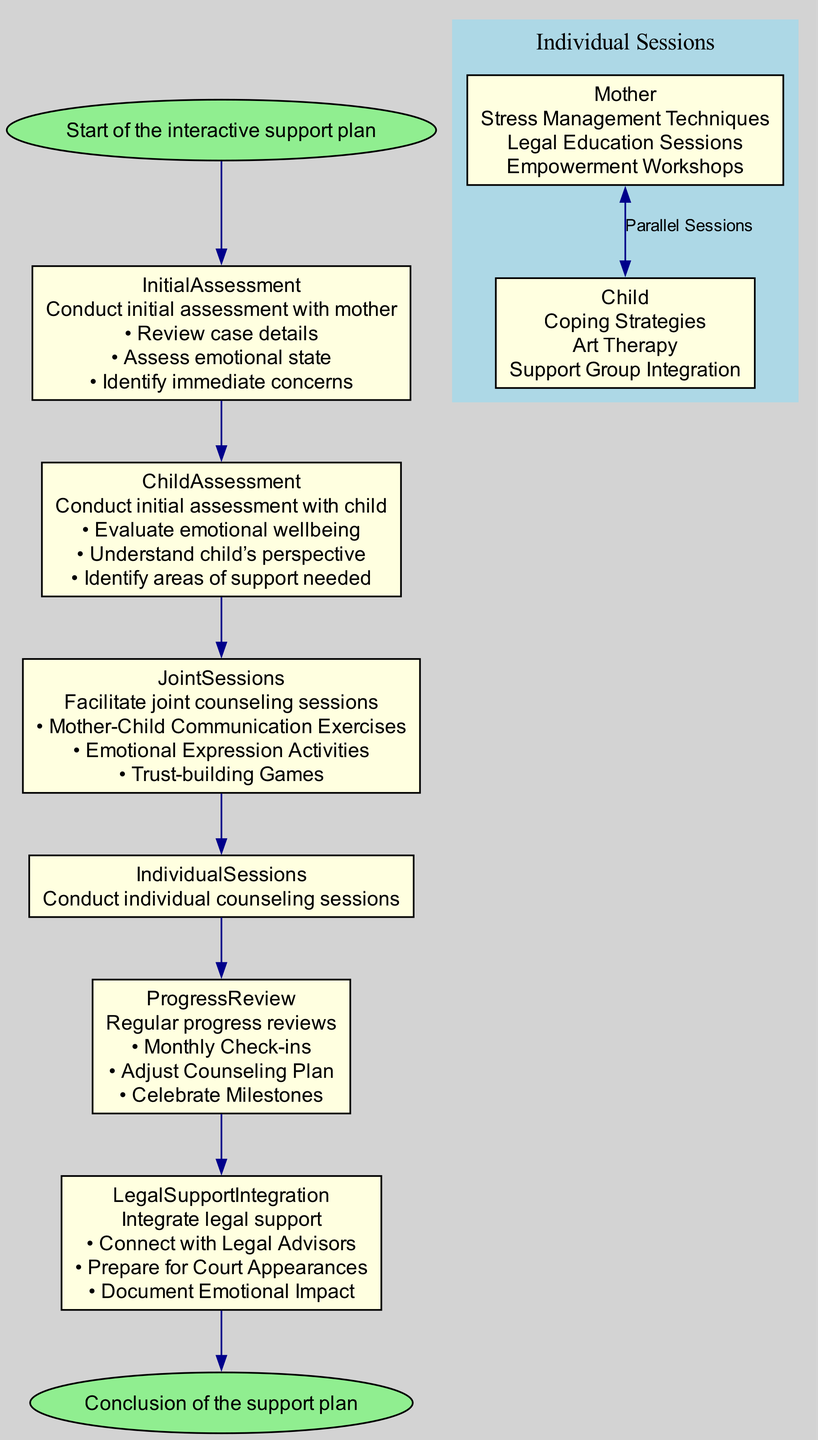What's the first step in the interactive support plan? The diagram indicates that the first step is "Start of the interactive support plan."
Answer: Start How many components are involved in the legal support integration? The diagram shows three components under legal support integration: "Connect with Legal Advisors," "Prepare for Court Appearances," and "Document Emotional Impact." Counting these gives a total of three components.
Answer: 3 What does 'Joint Sessions' aim to facilitate? The description of 'Joint Sessions' mentions that it aims to facilitate "Mother-Child Communication Exercises," "Emotional Expression Activities," and "Trust-building Games."
Answer: Facilitate joint counseling sessions What are the focus areas for the mother's individual counseling sessions? The diagram lists three focus areas under the mother's individual counseling sessions: "Stress Management Techniques," "Legal Education Sessions," and "Empowerment Workshops". The answer can be obtained by reviewing the corresponding node for individual sessions.
Answer: Stress Management Techniques, Legal Education Sessions, Empowerment Workshops Which session type follows the 'Child Assessment'? The diagram indicates that after 'Child Assessment', the next step is 'Joint Sessions.' This is determined by following the arrows leading from 'Child Assessment' to the next node.
Answer: Joint Sessions What type of activities are included in the 'Joint Sessions'? The 'Joint Sessions' node outlines three specific activities: "Mother-Child Communication Exercises," "Emotional Expression Activities," and "Trust-building Games." By reading the contents of this node, we identify the activities.
Answer: Mother-Child Communication Exercises, Emotional Expression Activities, Trust-building Games How is the 'Progress Review' structured in the diagram? The diagram specifies that 'Progress Review' consists of three components: "Monthly Check-ins," "Adjust Counseling Plan," and "Celebrate Milestones." This structure details the steps involved in the review process.
Answer: Monthly Check-ins, Adjust Counseling Plan, Celebrate Milestones What is described at the end of the flowchart? The last node in the flowchart describes the "Conclusion of the support plan." This can be identified by tracing the final path in the flow.
Answer: Conclusion of the support plan 